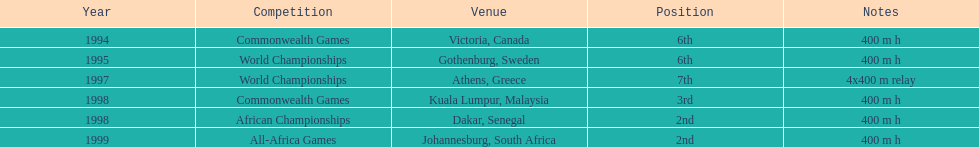In what year did ken harnden engage in over one competition? 1998. 